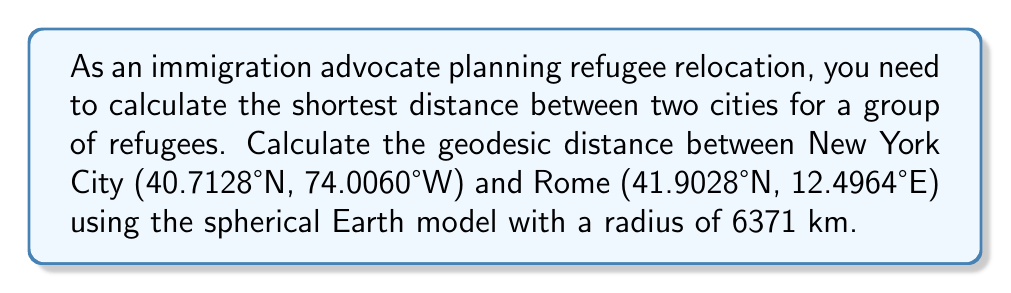Give your solution to this math problem. To calculate the geodesic distance between two points on a sphere, we use the Haversine formula:

1) Convert latitude and longitude to radians:
   $\phi_1 = 40.7128° \times \frac{\pi}{180} = 0.7101$ rad
   $\lambda_1 = -74.0060° \times \frac{\pi}{180} = -1.2915$ rad
   $\phi_2 = 41.9028° \times \frac{\pi}{180} = 0.7312$ rad
   $\lambda_2 = 12.4964° \times \frac{\pi}{180} = 0.2181$ rad

2) Calculate the central angle $\Delta\sigma$ using the Haversine formula:
   $$\Delta\sigma = 2 \arcsin\left(\sqrt{\sin^2\left(\frac{\phi_2-\phi_1}{2}\right) + \cos\phi_1 \cos\phi_2 \sin^2\left(\frac{\lambda_2-\lambda_1}{2}\right)}\right)$$

   $$\Delta\sigma = 2 \arcsin\left(\sqrt{\sin^2\left(\frac{0.7312-0.7101}{2}\right) + \cos(0.7101) \cos(0.7312) \sin^2\left(\frac{0.2181-(-1.2915)}{2}\right)}\right)$$

   $$\Delta\sigma = 2 \arcsin\left(\sqrt{0.0001 + 0.5539 \times 0.3642}\right) = 2 \arcsin(\sqrt{0.2019}) = 0.9298$$

3) Calculate the geodesic distance $d$ using the sphere's radius $R = 6371$ km:
   $$d = R \times \Delta\sigma = 6371 \times 0.9298 = 5923.93$$ km
Answer: 5924 km 